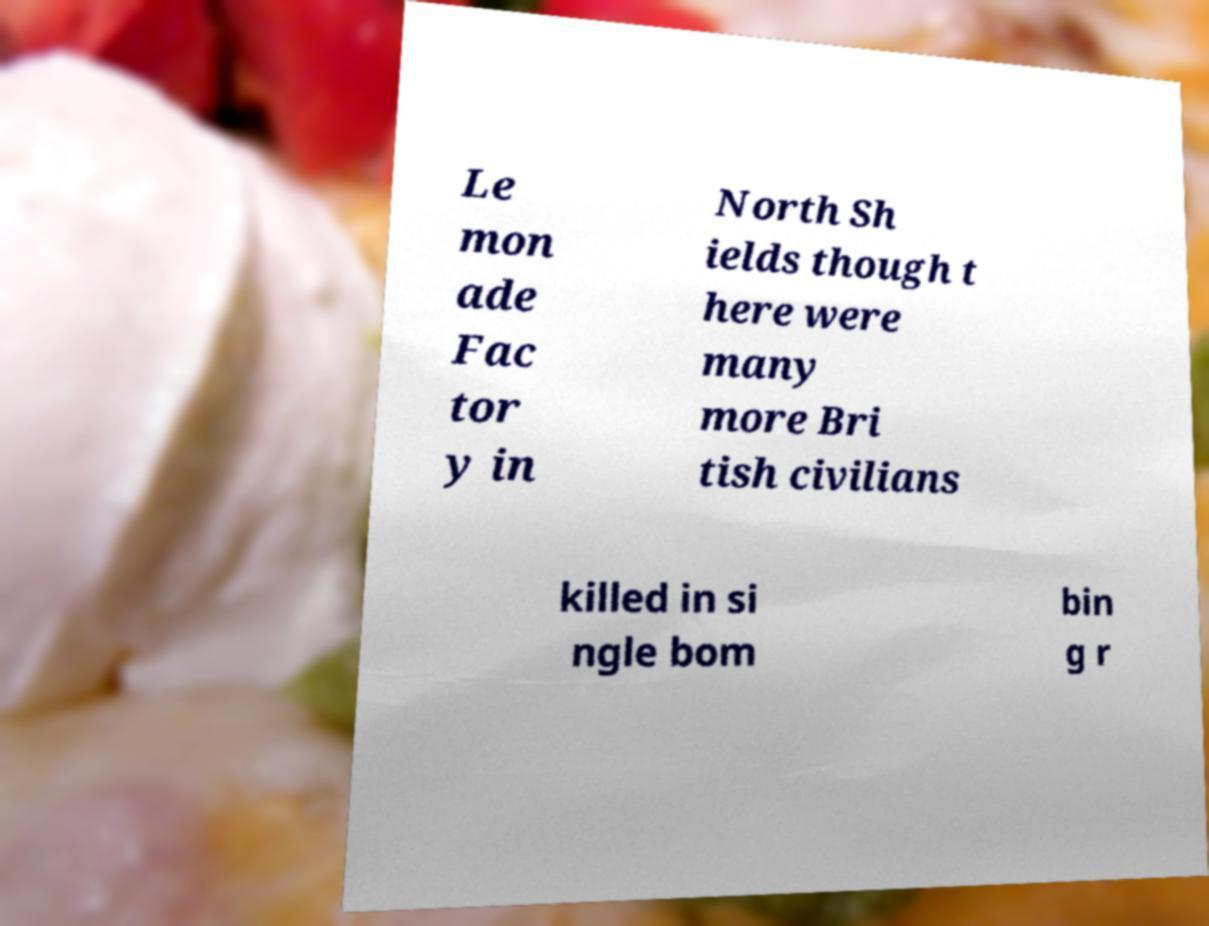For documentation purposes, I need the text within this image transcribed. Could you provide that? Le mon ade Fac tor y in North Sh ields though t here were many more Bri tish civilians killed in si ngle bom bin g r 